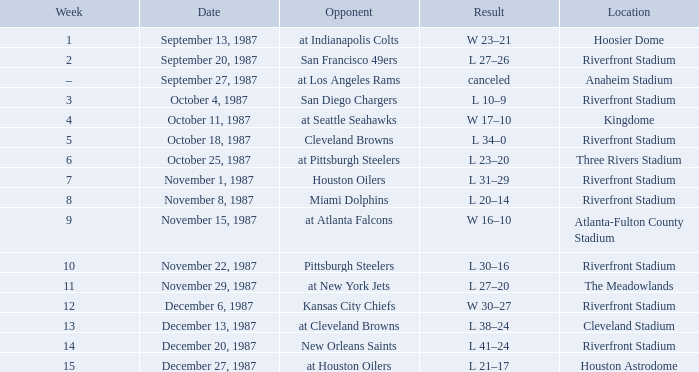What was the location of the game against the Houston Oilers? Riverfront Stadium. 